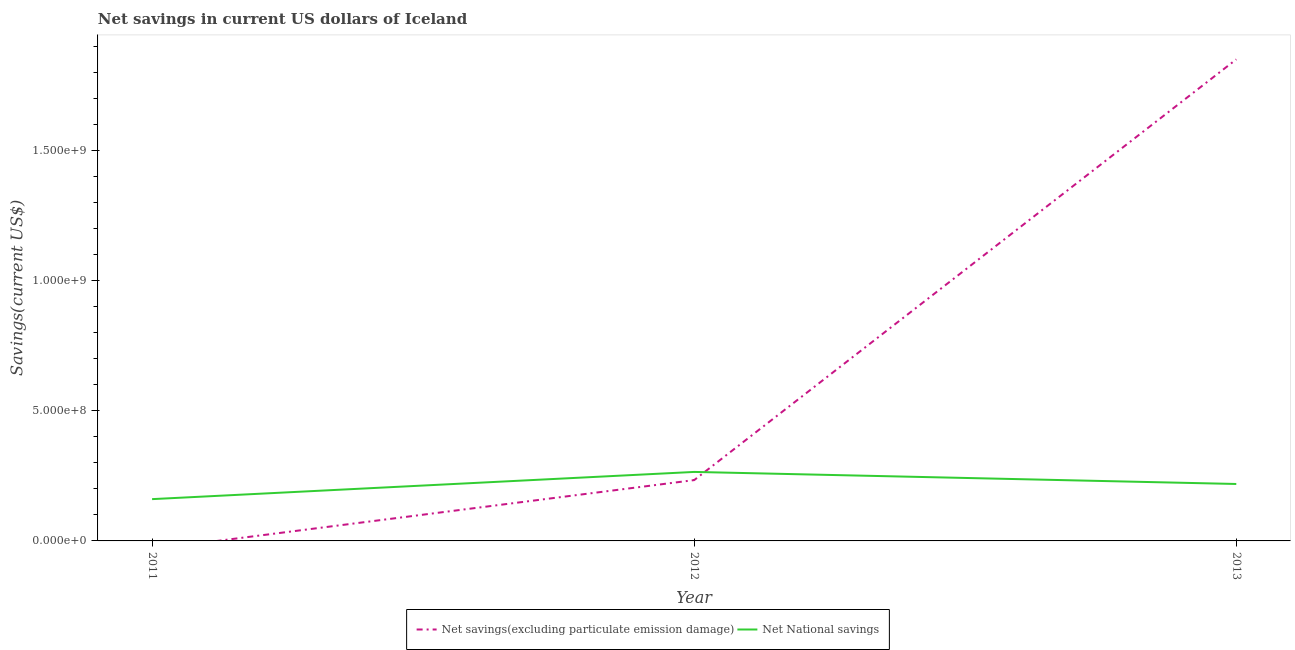How many different coloured lines are there?
Provide a short and direct response. 2. Does the line corresponding to net national savings intersect with the line corresponding to net savings(excluding particulate emission damage)?
Your response must be concise. Yes. Is the number of lines equal to the number of legend labels?
Provide a short and direct response. No. What is the net savings(excluding particulate emission damage) in 2012?
Your answer should be very brief. 2.34e+08. Across all years, what is the maximum net national savings?
Offer a terse response. 2.65e+08. What is the total net national savings in the graph?
Give a very brief answer. 6.44e+08. What is the difference between the net national savings in 2011 and that in 2013?
Your response must be concise. -5.82e+07. What is the difference between the net savings(excluding particulate emission damage) in 2012 and the net national savings in 2013?
Keep it short and to the point. 1.49e+07. What is the average net national savings per year?
Offer a terse response. 2.15e+08. In the year 2013, what is the difference between the net national savings and net savings(excluding particulate emission damage)?
Keep it short and to the point. -1.63e+09. In how many years, is the net savings(excluding particulate emission damage) greater than 1400000000 US$?
Keep it short and to the point. 1. What is the ratio of the net national savings in 2011 to that in 2012?
Your answer should be compact. 0.61. What is the difference between the highest and the second highest net national savings?
Offer a terse response. 4.63e+07. What is the difference between the highest and the lowest net national savings?
Ensure brevity in your answer.  1.05e+08. How many years are there in the graph?
Provide a short and direct response. 3. Are the values on the major ticks of Y-axis written in scientific E-notation?
Offer a terse response. Yes. Does the graph contain grids?
Your answer should be compact. No. Where does the legend appear in the graph?
Offer a very short reply. Bottom center. How many legend labels are there?
Provide a short and direct response. 2. What is the title of the graph?
Keep it short and to the point. Net savings in current US dollars of Iceland. Does "Commercial bank branches" appear as one of the legend labels in the graph?
Provide a succinct answer. No. What is the label or title of the X-axis?
Offer a very short reply. Year. What is the label or title of the Y-axis?
Ensure brevity in your answer.  Savings(current US$). What is the Savings(current US$) of Net savings(excluding particulate emission damage) in 2011?
Offer a terse response. 0. What is the Savings(current US$) of Net National savings in 2011?
Keep it short and to the point. 1.61e+08. What is the Savings(current US$) in Net savings(excluding particulate emission damage) in 2012?
Your answer should be compact. 2.34e+08. What is the Savings(current US$) in Net National savings in 2012?
Give a very brief answer. 2.65e+08. What is the Savings(current US$) of Net savings(excluding particulate emission damage) in 2013?
Ensure brevity in your answer.  1.85e+09. What is the Savings(current US$) in Net National savings in 2013?
Your response must be concise. 2.19e+08. Across all years, what is the maximum Savings(current US$) in Net savings(excluding particulate emission damage)?
Ensure brevity in your answer.  1.85e+09. Across all years, what is the maximum Savings(current US$) of Net National savings?
Give a very brief answer. 2.65e+08. Across all years, what is the minimum Savings(current US$) in Net savings(excluding particulate emission damage)?
Your response must be concise. 0. Across all years, what is the minimum Savings(current US$) of Net National savings?
Offer a very short reply. 1.61e+08. What is the total Savings(current US$) of Net savings(excluding particulate emission damage) in the graph?
Keep it short and to the point. 2.08e+09. What is the total Savings(current US$) of Net National savings in the graph?
Give a very brief answer. 6.44e+08. What is the difference between the Savings(current US$) in Net National savings in 2011 and that in 2012?
Offer a very short reply. -1.05e+08. What is the difference between the Savings(current US$) in Net National savings in 2011 and that in 2013?
Your answer should be very brief. -5.82e+07. What is the difference between the Savings(current US$) in Net savings(excluding particulate emission damage) in 2012 and that in 2013?
Your answer should be compact. -1.62e+09. What is the difference between the Savings(current US$) in Net National savings in 2012 and that in 2013?
Give a very brief answer. 4.63e+07. What is the difference between the Savings(current US$) of Net savings(excluding particulate emission damage) in 2012 and the Savings(current US$) of Net National savings in 2013?
Keep it short and to the point. 1.49e+07. What is the average Savings(current US$) of Net savings(excluding particulate emission damage) per year?
Your response must be concise. 6.95e+08. What is the average Savings(current US$) of Net National savings per year?
Offer a very short reply. 2.15e+08. In the year 2012, what is the difference between the Savings(current US$) of Net savings(excluding particulate emission damage) and Savings(current US$) of Net National savings?
Your answer should be compact. -3.14e+07. In the year 2013, what is the difference between the Savings(current US$) in Net savings(excluding particulate emission damage) and Savings(current US$) in Net National savings?
Your response must be concise. 1.63e+09. What is the ratio of the Savings(current US$) in Net National savings in 2011 to that in 2012?
Provide a short and direct response. 0.61. What is the ratio of the Savings(current US$) of Net National savings in 2011 to that in 2013?
Your response must be concise. 0.73. What is the ratio of the Savings(current US$) of Net savings(excluding particulate emission damage) in 2012 to that in 2013?
Provide a succinct answer. 0.13. What is the ratio of the Savings(current US$) in Net National savings in 2012 to that in 2013?
Keep it short and to the point. 1.21. What is the difference between the highest and the second highest Savings(current US$) in Net National savings?
Provide a succinct answer. 4.63e+07. What is the difference between the highest and the lowest Savings(current US$) of Net savings(excluding particulate emission damage)?
Your answer should be compact. 1.85e+09. What is the difference between the highest and the lowest Savings(current US$) of Net National savings?
Make the answer very short. 1.05e+08. 